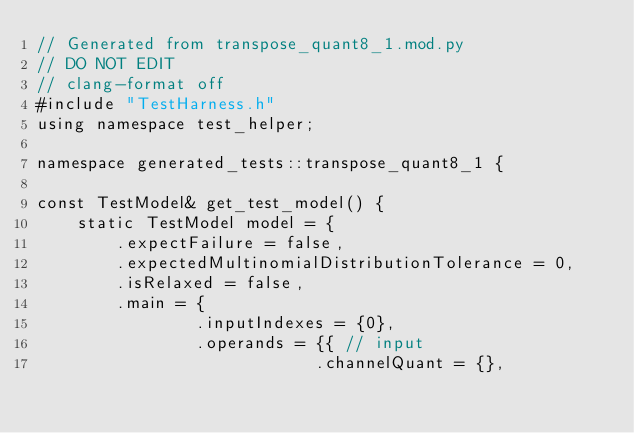Convert code to text. <code><loc_0><loc_0><loc_500><loc_500><_C++_>// Generated from transpose_quant8_1.mod.py
// DO NOT EDIT
// clang-format off
#include "TestHarness.h"
using namespace test_helper;

namespace generated_tests::transpose_quant8_1 {

const TestModel& get_test_model() {
    static TestModel model = {
        .expectFailure = false,
        .expectedMultinomialDistributionTolerance = 0,
        .isRelaxed = false,
        .main = {
                .inputIndexes = {0},
                .operands = {{ // input
                            .channelQuant = {},</code> 